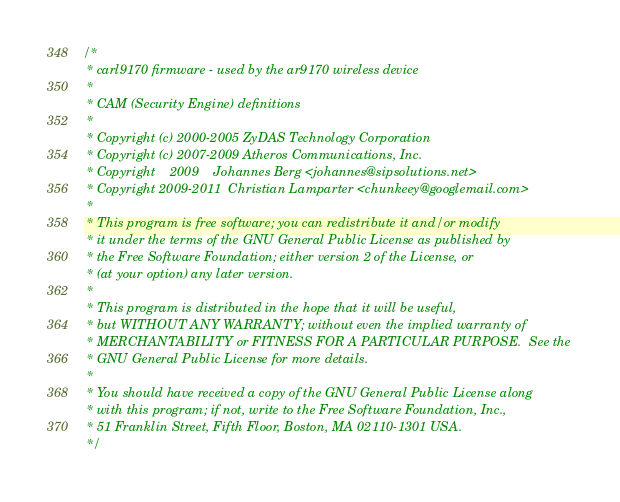<code> <loc_0><loc_0><loc_500><loc_500><_C_>/*
 * carl9170 firmware - used by the ar9170 wireless device
 *
 * CAM (Security Engine) definitions
 *
 * Copyright (c) 2000-2005 ZyDAS Technology Corporation
 * Copyright (c) 2007-2009 Atheros Communications, Inc.
 * Copyright	2009	Johannes Berg <johannes@sipsolutions.net>
 * Copyright 2009-2011	Christian Lamparter <chunkeey@googlemail.com>
 *
 * This program is free software; you can redistribute it and/or modify
 * it under the terms of the GNU General Public License as published by
 * the Free Software Foundation; either version 2 of the License, or
 * (at your option) any later version.
 *
 * This program is distributed in the hope that it will be useful,
 * but WITHOUT ANY WARRANTY; without even the implied warranty of
 * MERCHANTABILITY or FITNESS FOR A PARTICULAR PURPOSE.  See the
 * GNU General Public License for more details.
 *
 * You should have received a copy of the GNU General Public License along
 * with this program; if not, write to the Free Software Foundation, Inc.,
 * 51 Franklin Street, Fifth Floor, Boston, MA 02110-1301 USA.
 */
</code> 